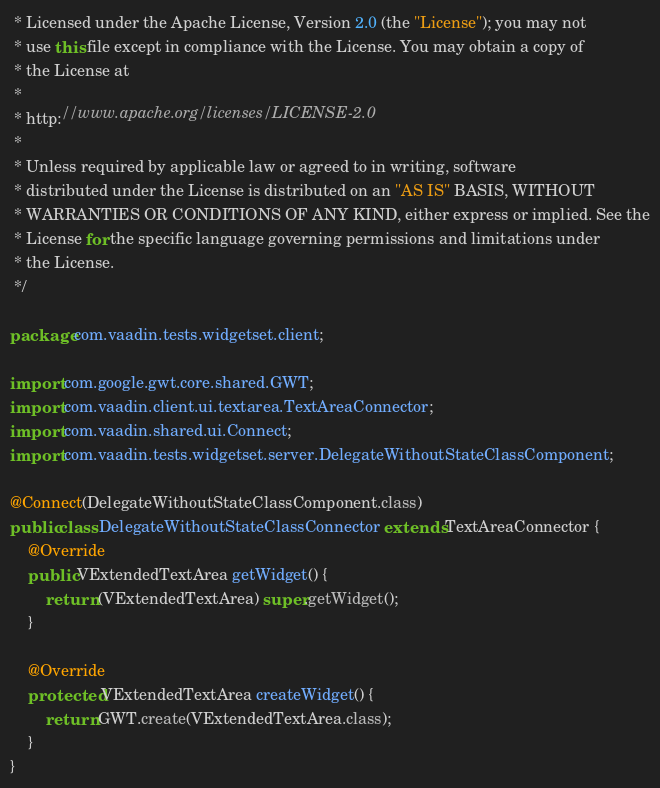Convert code to text. <code><loc_0><loc_0><loc_500><loc_500><_Java_> * Licensed under the Apache License, Version 2.0 (the "License"); you may not
 * use this file except in compliance with the License. You may obtain a copy of
 * the License at
 * 
 * http://www.apache.org/licenses/LICENSE-2.0
 * 
 * Unless required by applicable law or agreed to in writing, software
 * distributed under the License is distributed on an "AS IS" BASIS, WITHOUT
 * WARRANTIES OR CONDITIONS OF ANY KIND, either express or implied. See the
 * License for the specific language governing permissions and limitations under
 * the License.
 */

package com.vaadin.tests.widgetset.client;

import com.google.gwt.core.shared.GWT;
import com.vaadin.client.ui.textarea.TextAreaConnector;
import com.vaadin.shared.ui.Connect;
import com.vaadin.tests.widgetset.server.DelegateWithoutStateClassComponent;

@Connect(DelegateWithoutStateClassComponent.class)
public class DelegateWithoutStateClassConnector extends TextAreaConnector {
    @Override
    public VExtendedTextArea getWidget() {
        return (VExtendedTextArea) super.getWidget();
    }

    @Override
    protected VExtendedTextArea createWidget() {
        return GWT.create(VExtendedTextArea.class);
    }
}
</code> 